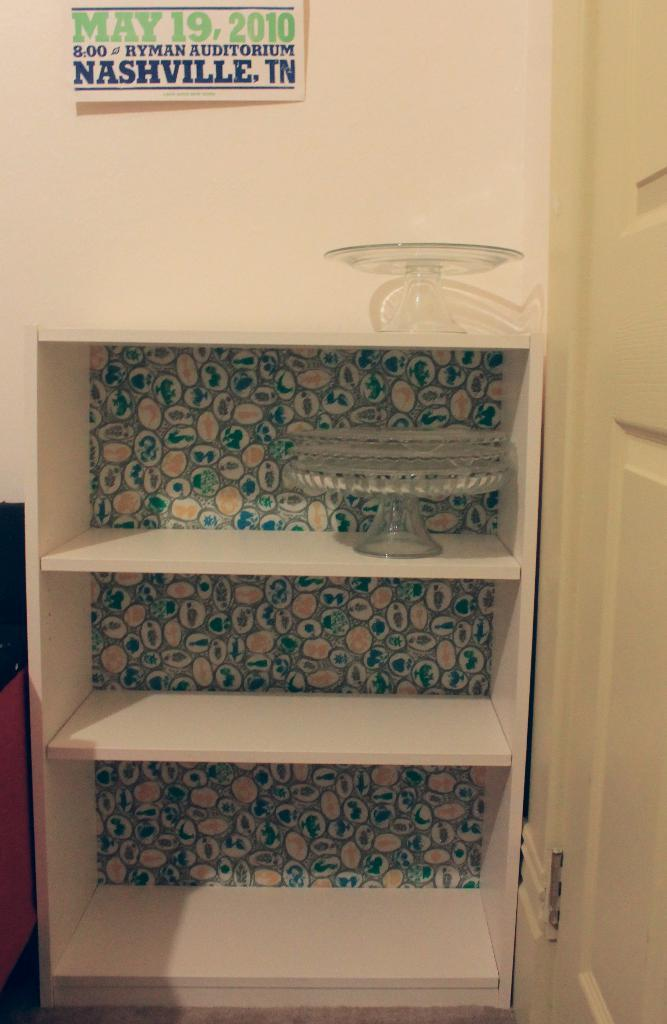What objects are visible in the image that are used for displaying cakes? There are cake stands in the image. How are the cake stands arranged in the image? The cake stands are placed in a rack. What can be seen in the background of the image? There is a wall in the background of the image. What is attached to the wall in the image? A board is pasted on the wall. What architectural feature is present on the right side of the image? There is a door on the right side of the image. How many fire hydrants are visible in the image? There are no fire hydrants present in the image. What type of debt is being discussed on the board pasted on the wall? There is no mention of debt on the board pasted on the wall in the image. 